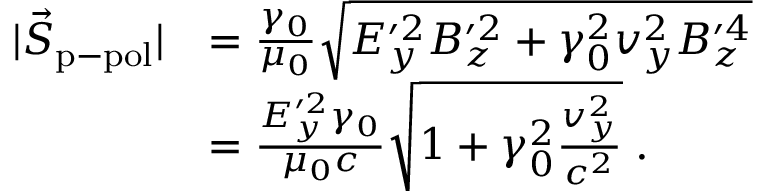<formula> <loc_0><loc_0><loc_500><loc_500>\begin{array} { r l } { | \vec { S } _ { p - p o l } | } & { = \frac { \gamma _ { 0 } } { \mu _ { 0 } } \sqrt { E _ { y } ^ { \prime 2 } B _ { z } ^ { \prime 2 } + \gamma _ { 0 } ^ { 2 } v _ { y } ^ { 2 } B _ { z } ^ { \prime 4 } } } \\ & { = \frac { E _ { y } ^ { \prime 2 } \gamma _ { 0 } } { \mu _ { 0 } c } \sqrt { 1 + \gamma _ { 0 } ^ { 2 } \frac { v _ { y } ^ { 2 } } { c ^ { 2 } } } \, . } \end{array}</formula> 